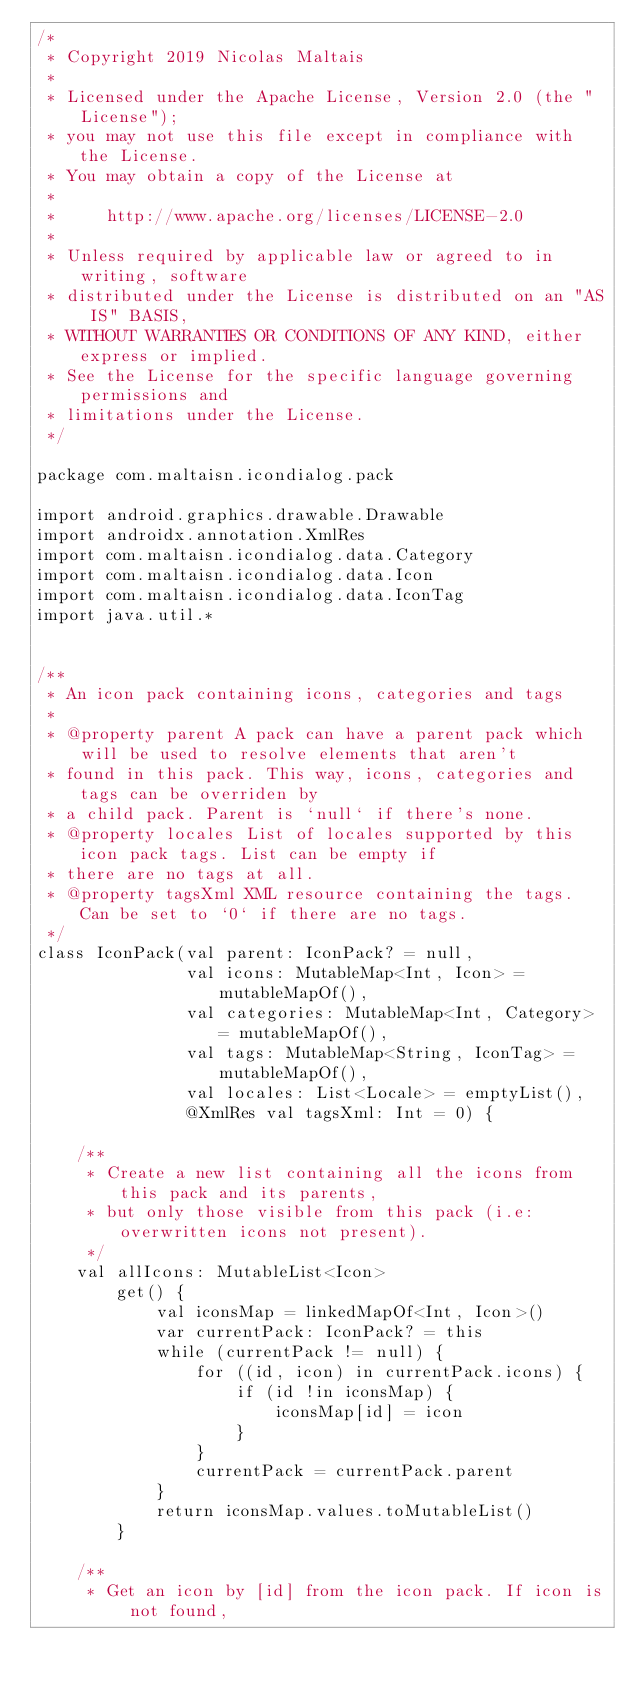<code> <loc_0><loc_0><loc_500><loc_500><_Kotlin_>/*
 * Copyright 2019 Nicolas Maltais
 *
 * Licensed under the Apache License, Version 2.0 (the "License");
 * you may not use this file except in compliance with the License.
 * You may obtain a copy of the License at
 *
 *     http://www.apache.org/licenses/LICENSE-2.0
 *
 * Unless required by applicable law or agreed to in writing, software
 * distributed under the License is distributed on an "AS IS" BASIS,
 * WITHOUT WARRANTIES OR CONDITIONS OF ANY KIND, either express or implied.
 * See the License for the specific language governing permissions and
 * limitations under the License.
 */

package com.maltaisn.icondialog.pack

import android.graphics.drawable.Drawable
import androidx.annotation.XmlRes
import com.maltaisn.icondialog.data.Category
import com.maltaisn.icondialog.data.Icon
import com.maltaisn.icondialog.data.IconTag
import java.util.*


/**
 * An icon pack containing icons, categories and tags
 *
 * @property parent A pack can have a parent pack which will be used to resolve elements that aren't
 * found in this pack. This way, icons, categories and tags can be overriden by
 * a child pack. Parent is `null` if there's none.
 * @property locales List of locales supported by this icon pack tags. List can be empty if
 * there are no tags at all.
 * @property tagsXml XML resource containing the tags. Can be set to `0` if there are no tags.
 */
class IconPack(val parent: IconPack? = null,
               val icons: MutableMap<Int, Icon> = mutableMapOf(),
               val categories: MutableMap<Int, Category> = mutableMapOf(),
               val tags: MutableMap<String, IconTag> = mutableMapOf(),
               val locales: List<Locale> = emptyList(),
               @XmlRes val tagsXml: Int = 0) {

    /**
     * Create a new list containing all the icons from this pack and its parents,
     * but only those visible from this pack (i.e: overwritten icons not present).
     */
    val allIcons: MutableList<Icon>
        get() {
            val iconsMap = linkedMapOf<Int, Icon>()
            var currentPack: IconPack? = this
            while (currentPack != null) {
                for ((id, icon) in currentPack.icons) {
                    if (id !in iconsMap) {
                        iconsMap[id] = icon
                    }
                }
                currentPack = currentPack.parent
            }
            return iconsMap.values.toMutableList()
        }

    /**
     * Get an icon by [id] from the icon pack. If icon is not found,</code> 